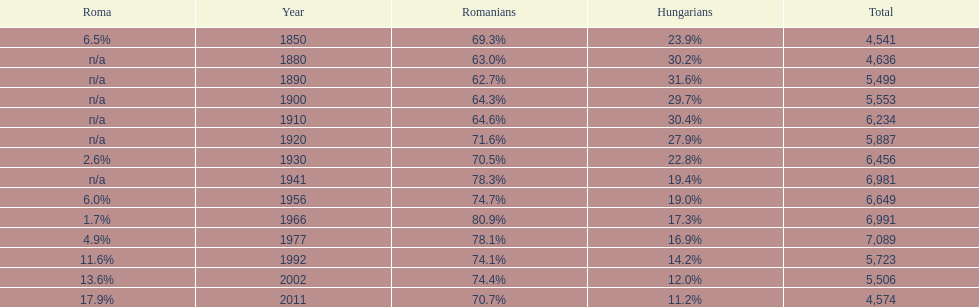What percent of the population were romanians according to the last year on this chart? 70.7%. 